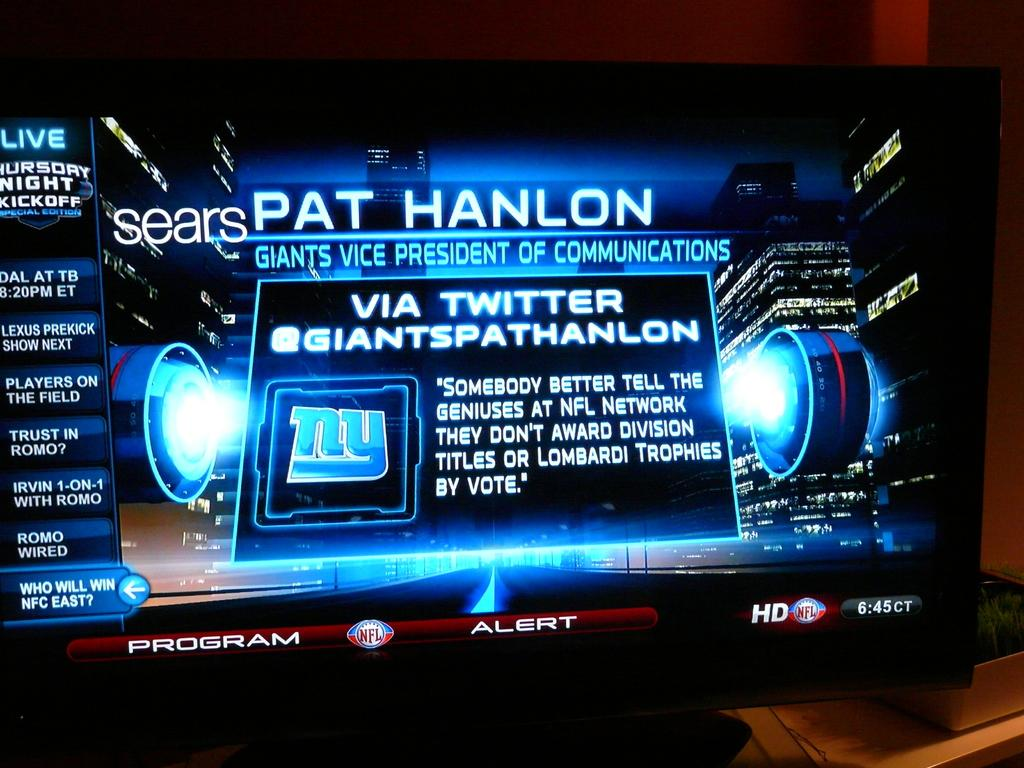<image>
Describe the image concisely. A TV screen shows information from a twitter feed regarding the NFL. 